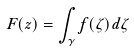Convert formula to latex. <formula><loc_0><loc_0><loc_500><loc_500>F ( z ) = \int _ { \gamma } f ( \zeta ) d \zeta</formula> 